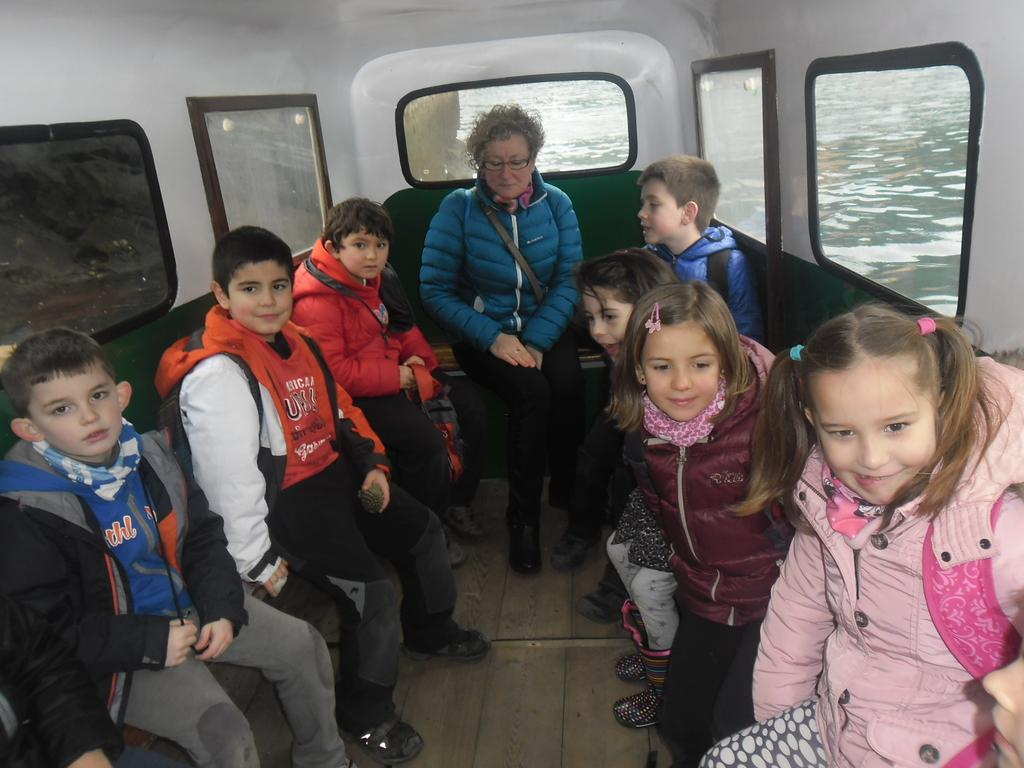Who is present in the image? There is a woman and a group of kids in the image. What are the woman and kids doing in the image? The woman and kids are sitting in a boat. Where is the boat located in the image? The boat is on the surface of water. What type of grape is being used for the operation in the image? There is no grape or operation present in the image. How many pins are visible on the woman's clothing in the image? There are no pins visible on the woman's clothing in the image. 